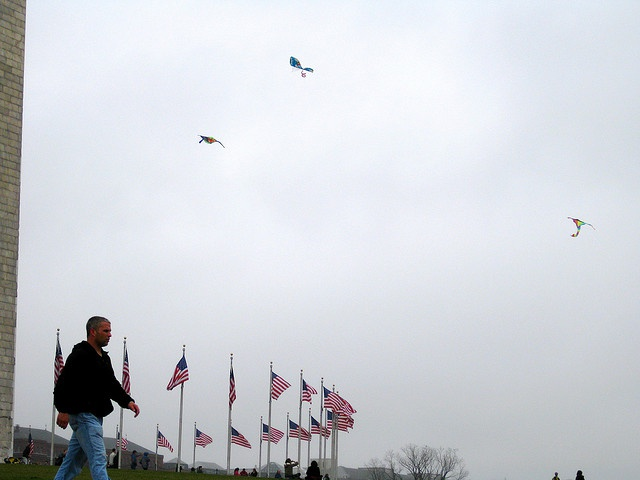Describe the objects in this image and their specific colors. I can see people in gray, black, darkblue, blue, and maroon tones, people in gray, black, darkgray, and lightgray tones, kite in gray, white, blue, and darkgray tones, people in black, gray, and darkgray tones, and people in gray and black tones in this image. 